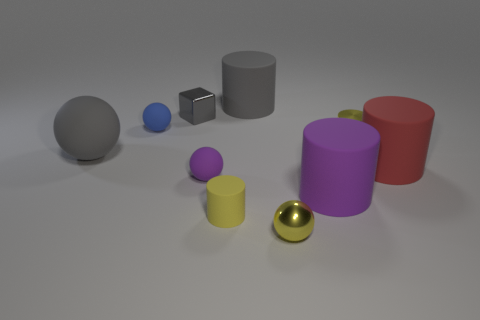What is the shape of the tiny matte object that is the same color as the metal cylinder?
Make the answer very short. Cylinder. Is the size of the purple cylinder on the right side of the blue sphere the same as the small gray thing?
Your answer should be very brief. No. What number of other objects are the same material as the big gray sphere?
Provide a succinct answer. 6. How many yellow objects are either large spheres or metallic cylinders?
Your response must be concise. 1. What is the size of the matte ball that is the same color as the tiny metal block?
Your response must be concise. Large. What number of tiny yellow matte cylinders are on the right side of the tiny metal cylinder?
Ensure brevity in your answer.  0. There is a rubber ball that is behind the yellow cylinder that is behind the tiny cylinder to the left of the tiny yellow ball; what size is it?
Offer a very short reply. Small. Is there a red rubber cylinder behind the big gray thing to the left of the big cylinder behind the tiny gray object?
Your answer should be very brief. No. Are there more small green cylinders than yellow matte things?
Offer a terse response. No. There is a small rubber thing that is behind the large red cylinder; what is its color?
Keep it short and to the point. Blue. 